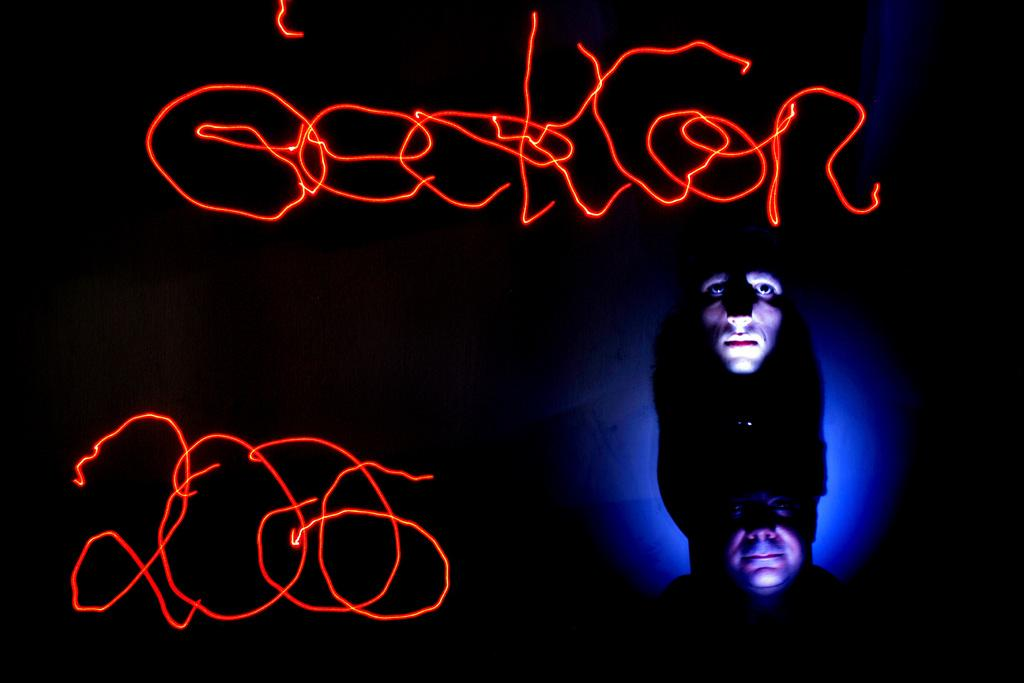How many persons' heads can be seen in the image? There are two persons' heads visible in the image. What else is present in the image besides the persons' heads? There is a text visible in the image. What is the color of the background in the image? The background of the image is dark. What type of scent can be smelled coming from the lizards in the image? There are no lizards present in the image, so it is not possible to determine what scent might be associated with them. 